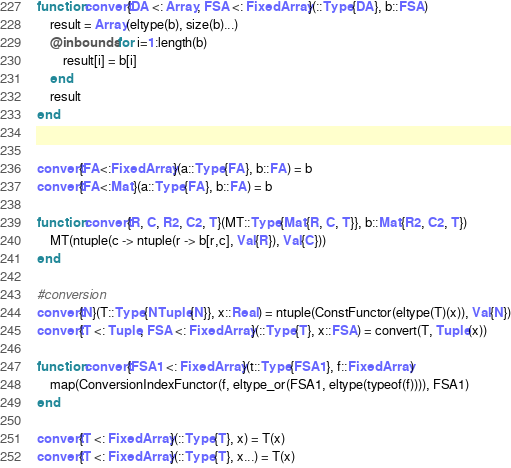Convert code to text. <code><loc_0><loc_0><loc_500><loc_500><_Julia_>function convert{DA <: Array, FSA <: FixedArray}(::Type{DA}, b::FSA)
    result = Array(eltype(b), size(b)...)
    @inbounds for i=1:length(b)
        result[i] = b[i]
    end
    result
end


convert{FA<:FixedArray}(a::Type{FA}, b::FA) = b
convert{FA<:Mat}(a::Type{FA}, b::FA) = b

function convert{R, C, R2, C2, T}(MT::Type{Mat{R, C, T}}, b::Mat{R2, C2, T})
    MT(ntuple(c -> ntuple(r -> b[r,c], Val{R}), Val{C}))
end

#conversion
convert{N}(T::Type{NTuple{N}}, x::Real) = ntuple(ConstFunctor(eltype(T)(x)), Val{N})
convert{T <: Tuple, FSA <: FixedArray}(::Type{T}, x::FSA) = convert(T, Tuple(x))

function convert{FSA1 <: FixedArray}(t::Type{FSA1}, f::FixedArray)
    map(ConversionIndexFunctor(f, eltype_or(FSA1, eltype(typeof(f)))), FSA1)
end

convert{T <: FixedArray}(::Type{T}, x) = T(x)
convert{T <: FixedArray}(::Type{T}, x...) = T(x)
</code> 